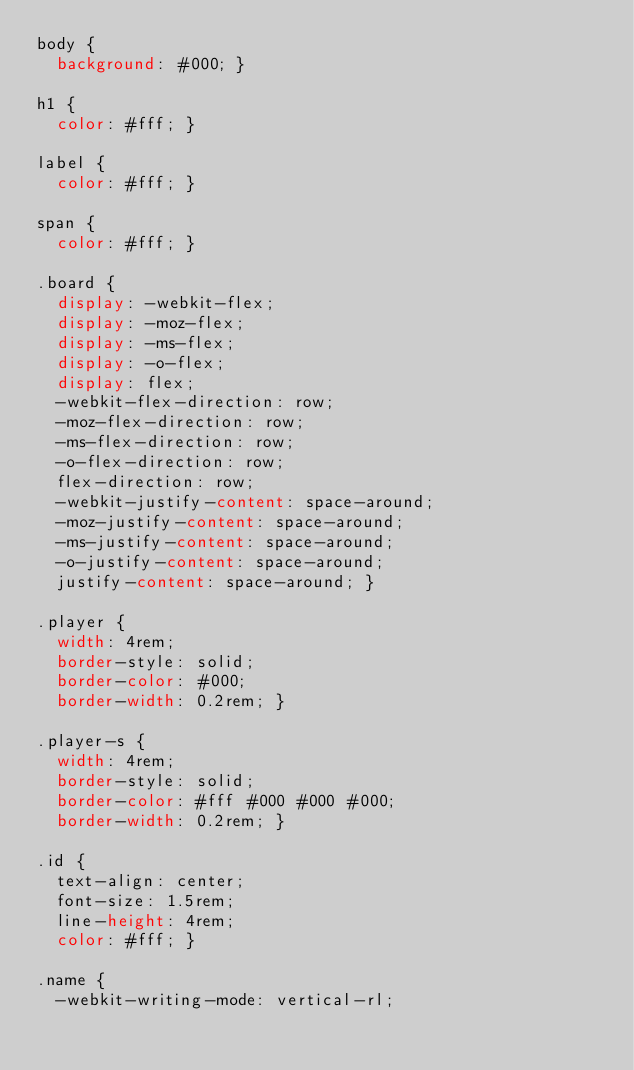<code> <loc_0><loc_0><loc_500><loc_500><_CSS_>body {
  background: #000; }

h1 {
  color: #fff; }

label {
  color: #fff; }

span {
  color: #fff; }

.board {
  display: -webkit-flex;
  display: -moz-flex;
  display: -ms-flex;
  display: -o-flex;
  display: flex;
  -webkit-flex-direction: row;
  -moz-flex-direction: row;
  -ms-flex-direction: row;
  -o-flex-direction: row;
  flex-direction: row;
  -webkit-justify-content: space-around;
  -moz-justify-content: space-around;
  -ms-justify-content: space-around;
  -o-justify-content: space-around;
  justify-content: space-around; }

.player {
  width: 4rem;
  border-style: solid;
  border-color: #000;
  border-width: 0.2rem; }

.player-s {
  width: 4rem;
  border-style: solid;
  border-color: #fff #000 #000 #000;
  border-width: 0.2rem; }

.id {
  text-align: center;
  font-size: 1.5rem;
  line-height: 4rem;
  color: #fff; }

.name {
  -webkit-writing-mode: vertical-rl;</code> 